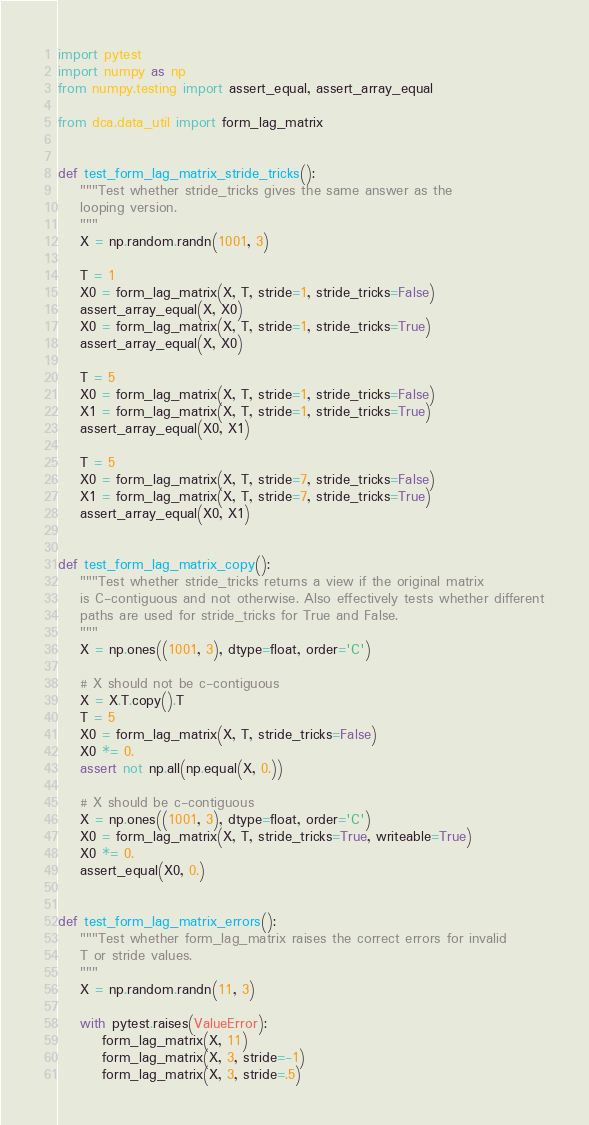<code> <loc_0><loc_0><loc_500><loc_500><_Python_>import pytest
import numpy as np
from numpy.testing import assert_equal, assert_array_equal

from dca.data_util import form_lag_matrix


def test_form_lag_matrix_stride_tricks():
    """Test whether stride_tricks gives the same answer as the
    looping version.
    """
    X = np.random.randn(1001, 3)

    T = 1
    X0 = form_lag_matrix(X, T, stride=1, stride_tricks=False)
    assert_array_equal(X, X0)
    X0 = form_lag_matrix(X, T, stride=1, stride_tricks=True)
    assert_array_equal(X, X0)

    T = 5
    X0 = form_lag_matrix(X, T, stride=1, stride_tricks=False)
    X1 = form_lag_matrix(X, T, stride=1, stride_tricks=True)
    assert_array_equal(X0, X1)

    T = 5
    X0 = form_lag_matrix(X, T, stride=7, stride_tricks=False)
    X1 = form_lag_matrix(X, T, stride=7, stride_tricks=True)
    assert_array_equal(X0, X1)


def test_form_lag_matrix_copy():
    """Test whether stride_tricks returns a view if the original matrix
    is C-contiguous and not otherwise. Also effectively tests whether different
    paths are used for stride_tricks for True and False.
    """
    X = np.ones((1001, 3), dtype=float, order='C')

    # X should not be c-contiguous
    X = X.T.copy().T
    T = 5
    X0 = form_lag_matrix(X, T, stride_tricks=False)
    X0 *= 0.
    assert not np.all(np.equal(X, 0.))

    # X should be c-contiguous
    X = np.ones((1001, 3), dtype=float, order='C')
    X0 = form_lag_matrix(X, T, stride_tricks=True, writeable=True)
    X0 *= 0.
    assert_equal(X0, 0.)


def test_form_lag_matrix_errors():
    """Test whether form_lag_matrix raises the correct errors for invalid
    T or stride values.
    """
    X = np.random.randn(11, 3)

    with pytest.raises(ValueError):
        form_lag_matrix(X, 11)
        form_lag_matrix(X, 3, stride=-1)
        form_lag_matrix(X, 3, stride=.5)
</code> 